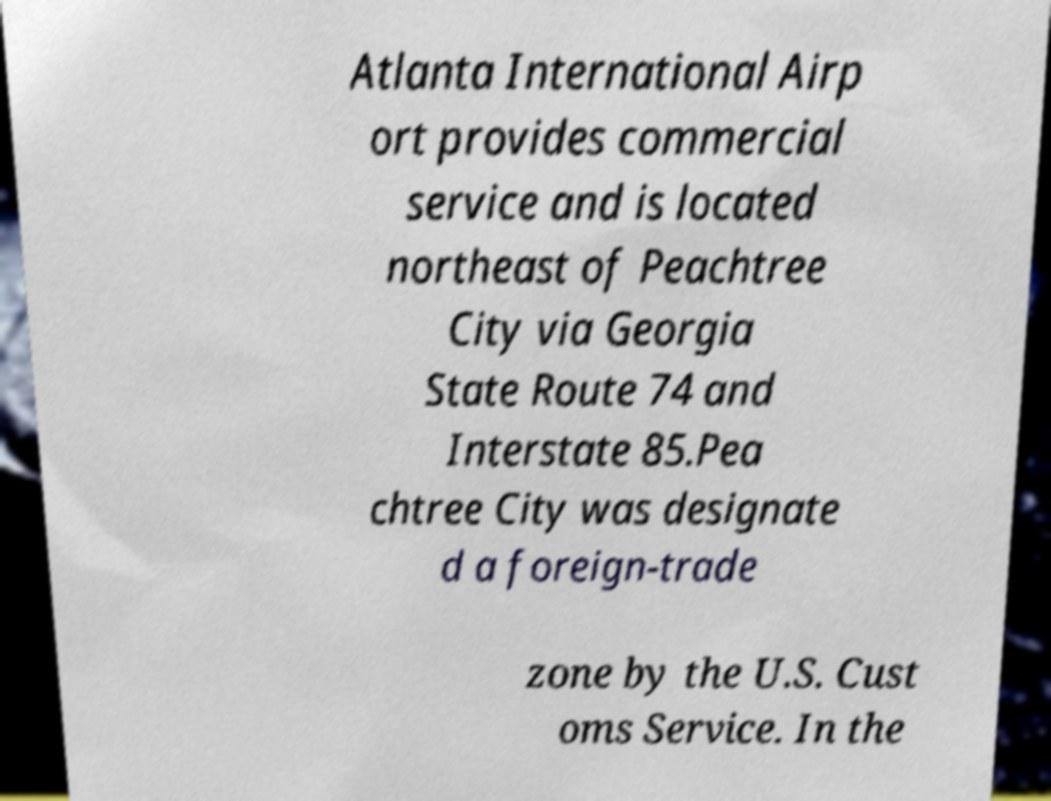Could you extract and type out the text from this image? Atlanta International Airp ort provides commercial service and is located northeast of Peachtree City via Georgia State Route 74 and Interstate 85.Pea chtree City was designate d a foreign-trade zone by the U.S. Cust oms Service. In the 